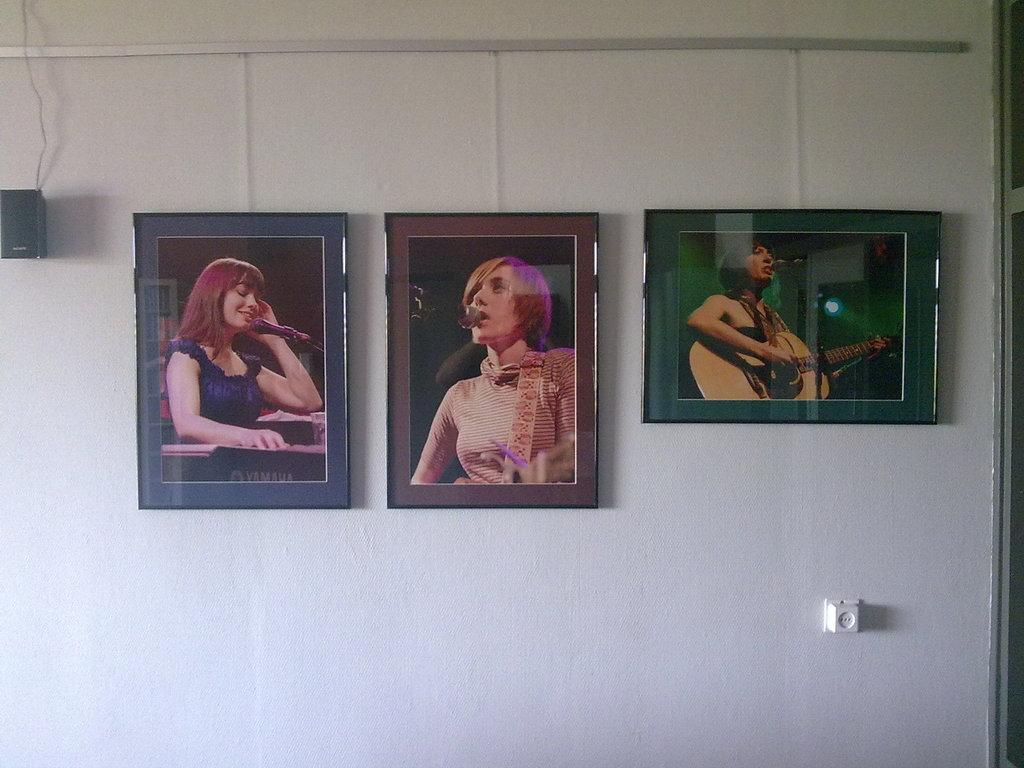What objects are present in the image? There are frames and a speaker on the wall in the image. Can you describe the speaker in the image? The speaker is mounted on the wall. What might the frames be used for? The frames could be used for displaying artwork or photographs. What type of food is being served on the plate in the image? There is no plate or food present in the image; it only features frames and a speaker on the wall. 